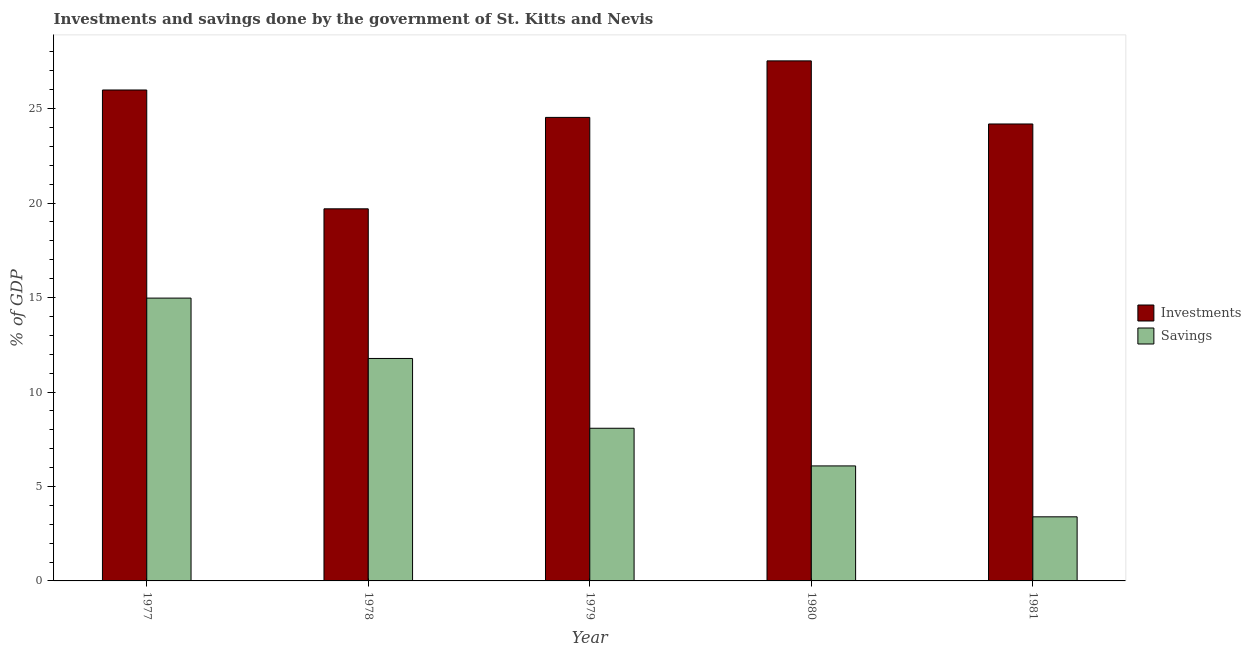How many different coloured bars are there?
Offer a very short reply. 2. How many groups of bars are there?
Ensure brevity in your answer.  5. Are the number of bars on each tick of the X-axis equal?
Provide a short and direct response. Yes. How many bars are there on the 2nd tick from the left?
Offer a very short reply. 2. How many bars are there on the 5th tick from the right?
Ensure brevity in your answer.  2. What is the label of the 2nd group of bars from the left?
Offer a terse response. 1978. In how many cases, is the number of bars for a given year not equal to the number of legend labels?
Provide a succinct answer. 0. What is the savings of government in 1980?
Your answer should be compact. 6.09. Across all years, what is the maximum investments of government?
Make the answer very short. 27.53. Across all years, what is the minimum investments of government?
Offer a terse response. 19.7. In which year was the investments of government maximum?
Your response must be concise. 1980. What is the total investments of government in the graph?
Make the answer very short. 121.94. What is the difference between the savings of government in 1977 and that in 1981?
Provide a short and direct response. 11.58. What is the difference between the savings of government in 1979 and the investments of government in 1981?
Your answer should be compact. 4.69. What is the average savings of government per year?
Keep it short and to the point. 8.86. In how many years, is the investments of government greater than 5 %?
Keep it short and to the point. 5. What is the ratio of the savings of government in 1977 to that in 1979?
Offer a terse response. 1.85. Is the difference between the investments of government in 1977 and 1980 greater than the difference between the savings of government in 1977 and 1980?
Keep it short and to the point. No. What is the difference between the highest and the second highest investments of government?
Offer a very short reply. 1.54. What is the difference between the highest and the lowest savings of government?
Provide a succinct answer. 11.58. What does the 2nd bar from the left in 1978 represents?
Keep it short and to the point. Savings. What does the 1st bar from the right in 1979 represents?
Provide a succinct answer. Savings. How many bars are there?
Your answer should be compact. 10. Are the values on the major ticks of Y-axis written in scientific E-notation?
Ensure brevity in your answer.  No. Where does the legend appear in the graph?
Provide a short and direct response. Center right. How many legend labels are there?
Ensure brevity in your answer.  2. What is the title of the graph?
Ensure brevity in your answer.  Investments and savings done by the government of St. Kitts and Nevis. What is the label or title of the Y-axis?
Your answer should be very brief. % of GDP. What is the % of GDP in Investments in 1977?
Your answer should be very brief. 25.99. What is the % of GDP of Savings in 1977?
Your response must be concise. 14.97. What is the % of GDP in Investments in 1978?
Your answer should be very brief. 19.7. What is the % of GDP of Savings in 1978?
Make the answer very short. 11.78. What is the % of GDP in Investments in 1979?
Your response must be concise. 24.54. What is the % of GDP of Savings in 1979?
Your answer should be very brief. 8.08. What is the % of GDP in Investments in 1980?
Offer a very short reply. 27.53. What is the % of GDP of Savings in 1980?
Provide a short and direct response. 6.09. What is the % of GDP in Investments in 1981?
Your answer should be very brief. 24.19. What is the % of GDP of Savings in 1981?
Provide a short and direct response. 3.39. Across all years, what is the maximum % of GDP in Investments?
Make the answer very short. 27.53. Across all years, what is the maximum % of GDP in Savings?
Make the answer very short. 14.97. Across all years, what is the minimum % of GDP of Investments?
Offer a very short reply. 19.7. Across all years, what is the minimum % of GDP in Savings?
Ensure brevity in your answer.  3.39. What is the total % of GDP in Investments in the graph?
Your response must be concise. 121.94. What is the total % of GDP of Savings in the graph?
Offer a very short reply. 44.31. What is the difference between the % of GDP of Investments in 1977 and that in 1978?
Your answer should be very brief. 6.29. What is the difference between the % of GDP of Savings in 1977 and that in 1978?
Provide a succinct answer. 3.19. What is the difference between the % of GDP of Investments in 1977 and that in 1979?
Give a very brief answer. 1.45. What is the difference between the % of GDP of Savings in 1977 and that in 1979?
Provide a succinct answer. 6.89. What is the difference between the % of GDP in Investments in 1977 and that in 1980?
Keep it short and to the point. -1.54. What is the difference between the % of GDP of Savings in 1977 and that in 1980?
Your answer should be compact. 8.88. What is the difference between the % of GDP of Investments in 1977 and that in 1981?
Your answer should be compact. 1.8. What is the difference between the % of GDP of Savings in 1977 and that in 1981?
Your answer should be very brief. 11.58. What is the difference between the % of GDP in Investments in 1978 and that in 1979?
Ensure brevity in your answer.  -4.84. What is the difference between the % of GDP of Savings in 1978 and that in 1979?
Your answer should be very brief. 3.69. What is the difference between the % of GDP in Investments in 1978 and that in 1980?
Offer a terse response. -7.83. What is the difference between the % of GDP of Savings in 1978 and that in 1980?
Offer a very short reply. 5.69. What is the difference between the % of GDP of Investments in 1978 and that in 1981?
Your response must be concise. -4.49. What is the difference between the % of GDP in Savings in 1978 and that in 1981?
Ensure brevity in your answer.  8.38. What is the difference between the % of GDP of Investments in 1979 and that in 1980?
Ensure brevity in your answer.  -2.99. What is the difference between the % of GDP in Savings in 1979 and that in 1980?
Your answer should be compact. 1.99. What is the difference between the % of GDP in Investments in 1979 and that in 1981?
Give a very brief answer. 0.35. What is the difference between the % of GDP of Savings in 1979 and that in 1981?
Ensure brevity in your answer.  4.69. What is the difference between the % of GDP of Investments in 1980 and that in 1981?
Keep it short and to the point. 3.34. What is the difference between the % of GDP in Savings in 1980 and that in 1981?
Offer a terse response. 2.69. What is the difference between the % of GDP of Investments in 1977 and the % of GDP of Savings in 1978?
Give a very brief answer. 14.21. What is the difference between the % of GDP in Investments in 1977 and the % of GDP in Savings in 1979?
Make the answer very short. 17.91. What is the difference between the % of GDP of Investments in 1977 and the % of GDP of Savings in 1980?
Your response must be concise. 19.9. What is the difference between the % of GDP of Investments in 1977 and the % of GDP of Savings in 1981?
Keep it short and to the point. 22.59. What is the difference between the % of GDP in Investments in 1978 and the % of GDP in Savings in 1979?
Provide a short and direct response. 11.62. What is the difference between the % of GDP in Investments in 1978 and the % of GDP in Savings in 1980?
Your response must be concise. 13.61. What is the difference between the % of GDP in Investments in 1978 and the % of GDP in Savings in 1981?
Ensure brevity in your answer.  16.3. What is the difference between the % of GDP in Investments in 1979 and the % of GDP in Savings in 1980?
Provide a short and direct response. 18.45. What is the difference between the % of GDP in Investments in 1979 and the % of GDP in Savings in 1981?
Offer a very short reply. 21.14. What is the difference between the % of GDP in Investments in 1980 and the % of GDP in Savings in 1981?
Offer a terse response. 24.13. What is the average % of GDP in Investments per year?
Your answer should be compact. 24.39. What is the average % of GDP of Savings per year?
Keep it short and to the point. 8.86. In the year 1977, what is the difference between the % of GDP of Investments and % of GDP of Savings?
Your response must be concise. 11.02. In the year 1978, what is the difference between the % of GDP in Investments and % of GDP in Savings?
Make the answer very short. 7.92. In the year 1979, what is the difference between the % of GDP of Investments and % of GDP of Savings?
Ensure brevity in your answer.  16.45. In the year 1980, what is the difference between the % of GDP in Investments and % of GDP in Savings?
Your answer should be compact. 21.44. In the year 1981, what is the difference between the % of GDP in Investments and % of GDP in Savings?
Your answer should be very brief. 20.79. What is the ratio of the % of GDP of Investments in 1977 to that in 1978?
Offer a very short reply. 1.32. What is the ratio of the % of GDP in Savings in 1977 to that in 1978?
Your answer should be very brief. 1.27. What is the ratio of the % of GDP of Investments in 1977 to that in 1979?
Offer a terse response. 1.06. What is the ratio of the % of GDP in Savings in 1977 to that in 1979?
Give a very brief answer. 1.85. What is the ratio of the % of GDP of Investments in 1977 to that in 1980?
Keep it short and to the point. 0.94. What is the ratio of the % of GDP in Savings in 1977 to that in 1980?
Provide a short and direct response. 2.46. What is the ratio of the % of GDP of Investments in 1977 to that in 1981?
Your answer should be compact. 1.07. What is the ratio of the % of GDP of Savings in 1977 to that in 1981?
Offer a terse response. 4.41. What is the ratio of the % of GDP in Investments in 1978 to that in 1979?
Your answer should be very brief. 0.8. What is the ratio of the % of GDP of Savings in 1978 to that in 1979?
Provide a short and direct response. 1.46. What is the ratio of the % of GDP of Investments in 1978 to that in 1980?
Ensure brevity in your answer.  0.72. What is the ratio of the % of GDP of Savings in 1978 to that in 1980?
Give a very brief answer. 1.93. What is the ratio of the % of GDP of Investments in 1978 to that in 1981?
Your answer should be compact. 0.81. What is the ratio of the % of GDP in Savings in 1978 to that in 1981?
Your answer should be very brief. 3.47. What is the ratio of the % of GDP in Investments in 1979 to that in 1980?
Your response must be concise. 0.89. What is the ratio of the % of GDP in Savings in 1979 to that in 1980?
Offer a terse response. 1.33. What is the ratio of the % of GDP of Investments in 1979 to that in 1981?
Ensure brevity in your answer.  1.01. What is the ratio of the % of GDP in Savings in 1979 to that in 1981?
Offer a very short reply. 2.38. What is the ratio of the % of GDP in Investments in 1980 to that in 1981?
Offer a terse response. 1.14. What is the ratio of the % of GDP of Savings in 1980 to that in 1981?
Give a very brief answer. 1.79. What is the difference between the highest and the second highest % of GDP of Investments?
Make the answer very short. 1.54. What is the difference between the highest and the second highest % of GDP of Savings?
Your answer should be very brief. 3.19. What is the difference between the highest and the lowest % of GDP of Investments?
Provide a succinct answer. 7.83. What is the difference between the highest and the lowest % of GDP of Savings?
Offer a very short reply. 11.58. 